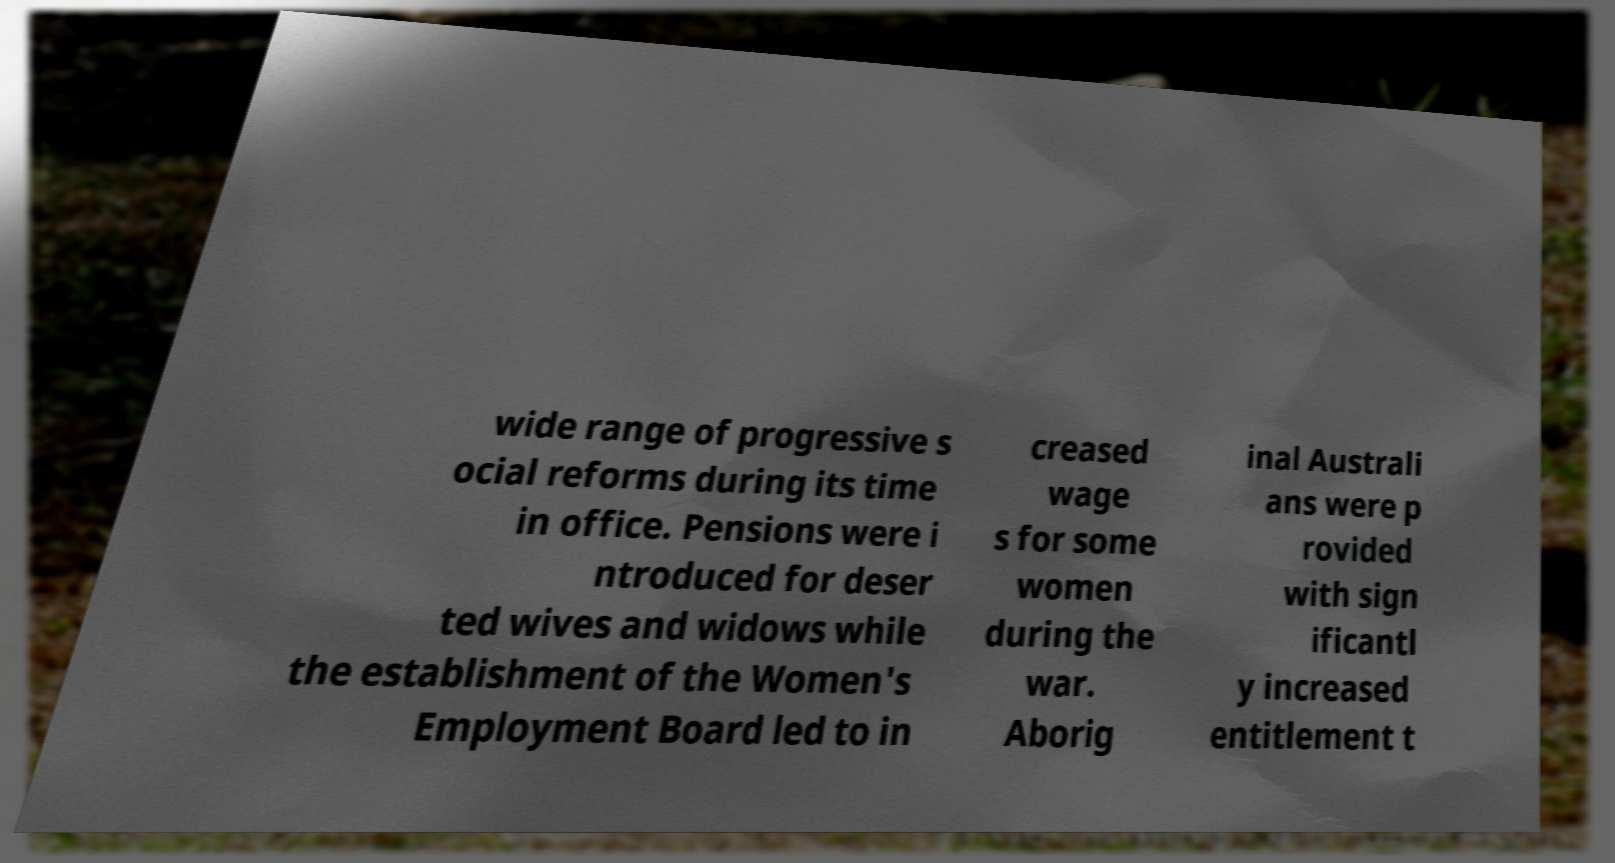Can you read and provide the text displayed in the image?This photo seems to have some interesting text. Can you extract and type it out for me? wide range of progressive s ocial reforms during its time in office. Pensions were i ntroduced for deser ted wives and widows while the establishment of the Women's Employment Board led to in creased wage s for some women during the war. Aborig inal Australi ans were p rovided with sign ificantl y increased entitlement t 